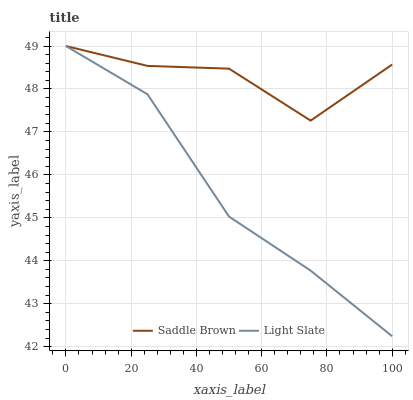Does Light Slate have the minimum area under the curve?
Answer yes or no. Yes. Does Saddle Brown have the maximum area under the curve?
Answer yes or no. Yes. Does Saddle Brown have the minimum area under the curve?
Answer yes or no. No. Is Light Slate the smoothest?
Answer yes or no. Yes. Is Saddle Brown the roughest?
Answer yes or no. Yes. Is Saddle Brown the smoothest?
Answer yes or no. No. Does Light Slate have the lowest value?
Answer yes or no. Yes. Does Saddle Brown have the lowest value?
Answer yes or no. No. Does Saddle Brown have the highest value?
Answer yes or no. Yes. Does Light Slate intersect Saddle Brown?
Answer yes or no. Yes. Is Light Slate less than Saddle Brown?
Answer yes or no. No. Is Light Slate greater than Saddle Brown?
Answer yes or no. No. 